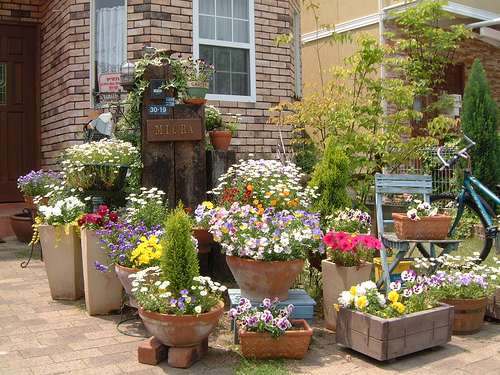Identify the text contained in this image. MIURA 30 19 